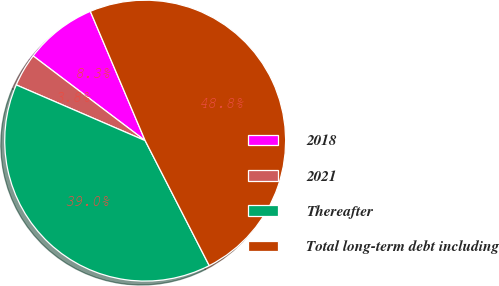Convert chart. <chart><loc_0><loc_0><loc_500><loc_500><pie_chart><fcel>2018<fcel>2021<fcel>Thereafter<fcel>Total long-term debt including<nl><fcel>8.31%<fcel>3.81%<fcel>39.03%<fcel>48.84%<nl></chart> 